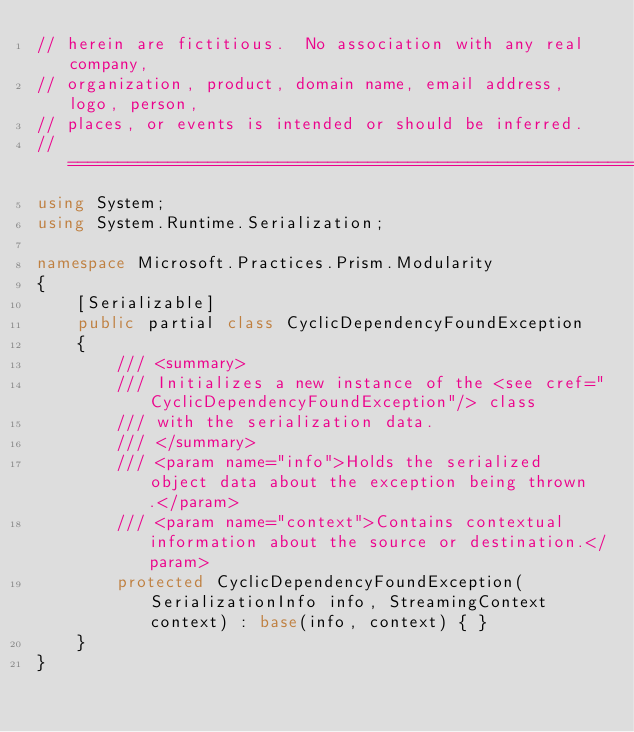<code> <loc_0><loc_0><loc_500><loc_500><_C#_>// herein are fictitious.  No association with any real company,
// organization, product, domain name, email address, logo, person,
// places, or events is intended or should be inferred.
//===================================================================================
using System;
using System.Runtime.Serialization;

namespace Microsoft.Practices.Prism.Modularity
{
    [Serializable]
    public partial class CyclicDependencyFoundException 
    {
        /// <summary>
        /// Initializes a new instance of the <see cref="CyclicDependencyFoundException"/> class
        /// with the serialization data.
        /// </summary>
        /// <param name="info">Holds the serialized object data about the exception being thrown.</param>
        /// <param name="context">Contains contextual information about the source or destination.</param>
        protected CyclicDependencyFoundException(SerializationInfo info, StreamingContext context) : base(info, context) { }
    }
}
</code> 